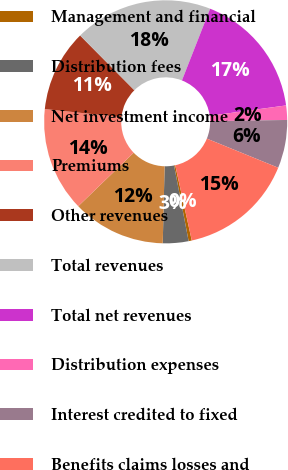Convert chart. <chart><loc_0><loc_0><loc_500><loc_500><pie_chart><fcel>Management and financial<fcel>Distribution fees<fcel>Net investment income<fcel>Premiums<fcel>Other revenues<fcel>Total revenues<fcel>Total net revenues<fcel>Distribution expenses<fcel>Interest credited to fixed<fcel>Benefits claims losses and<nl><fcel>0.42%<fcel>3.41%<fcel>12.4%<fcel>13.89%<fcel>10.9%<fcel>18.39%<fcel>16.89%<fcel>1.91%<fcel>6.41%<fcel>15.39%<nl></chart> 